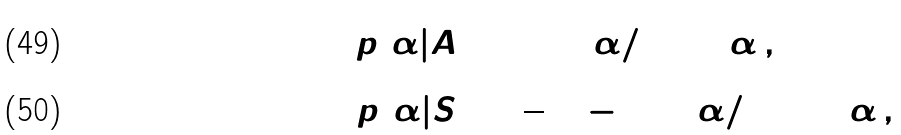<formula> <loc_0><loc_0><loc_500><loc_500>p ( \alpha | A ) & = \sin ^ { 2 } ( \alpha / 2 ) \sin \alpha \, , \\ p ( \alpha | S ) & = \frac { 1 } { 3 } ( 2 - \sin ^ { 2 } ( \alpha / 2 ) ) \sin \alpha \, ,</formula> 